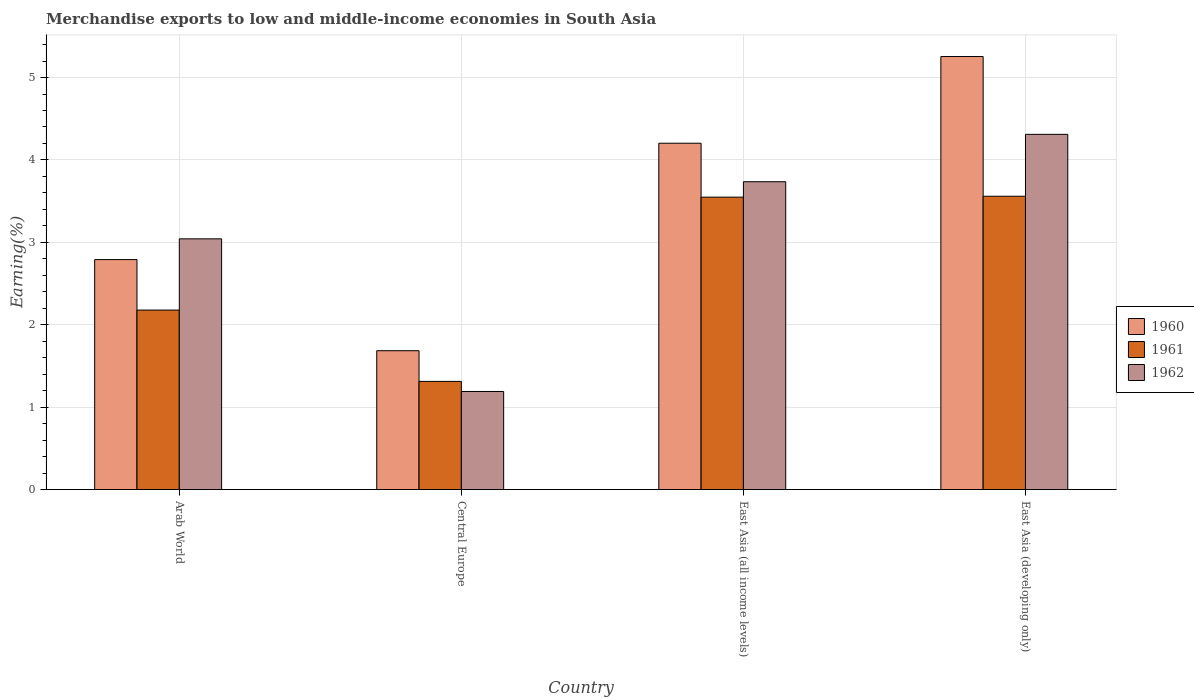How many different coloured bars are there?
Your answer should be compact. 3. How many groups of bars are there?
Offer a terse response. 4. Are the number of bars on each tick of the X-axis equal?
Your response must be concise. Yes. How many bars are there on the 1st tick from the left?
Offer a very short reply. 3. How many bars are there on the 3rd tick from the right?
Offer a terse response. 3. What is the label of the 2nd group of bars from the left?
Make the answer very short. Central Europe. What is the percentage of amount earned from merchandise exports in 1961 in East Asia (all income levels)?
Offer a terse response. 3.55. Across all countries, what is the maximum percentage of amount earned from merchandise exports in 1960?
Your answer should be compact. 5.26. Across all countries, what is the minimum percentage of amount earned from merchandise exports in 1962?
Provide a succinct answer. 1.19. In which country was the percentage of amount earned from merchandise exports in 1962 maximum?
Ensure brevity in your answer.  East Asia (developing only). In which country was the percentage of amount earned from merchandise exports in 1962 minimum?
Ensure brevity in your answer.  Central Europe. What is the total percentage of amount earned from merchandise exports in 1960 in the graph?
Give a very brief answer. 13.93. What is the difference between the percentage of amount earned from merchandise exports in 1961 in Arab World and that in East Asia (all income levels)?
Your response must be concise. -1.37. What is the difference between the percentage of amount earned from merchandise exports in 1962 in East Asia (all income levels) and the percentage of amount earned from merchandise exports in 1960 in Arab World?
Keep it short and to the point. 0.94. What is the average percentage of amount earned from merchandise exports in 1962 per country?
Your answer should be very brief. 3.07. What is the difference between the percentage of amount earned from merchandise exports of/in 1961 and percentage of amount earned from merchandise exports of/in 1960 in Arab World?
Offer a very short reply. -0.61. What is the ratio of the percentage of amount earned from merchandise exports in 1962 in Central Europe to that in East Asia (all income levels)?
Your response must be concise. 0.32. Is the percentage of amount earned from merchandise exports in 1961 in Arab World less than that in East Asia (all income levels)?
Keep it short and to the point. Yes. What is the difference between the highest and the second highest percentage of amount earned from merchandise exports in 1960?
Make the answer very short. -1.41. What is the difference between the highest and the lowest percentage of amount earned from merchandise exports in 1961?
Offer a very short reply. 2.25. What does the 3rd bar from the left in Arab World represents?
Offer a very short reply. 1962. Is it the case that in every country, the sum of the percentage of amount earned from merchandise exports in 1962 and percentage of amount earned from merchandise exports in 1961 is greater than the percentage of amount earned from merchandise exports in 1960?
Your answer should be compact. Yes. How many bars are there?
Offer a terse response. 12. Are all the bars in the graph horizontal?
Give a very brief answer. No. How many countries are there in the graph?
Your response must be concise. 4. Are the values on the major ticks of Y-axis written in scientific E-notation?
Keep it short and to the point. No. Does the graph contain grids?
Your answer should be very brief. Yes. Where does the legend appear in the graph?
Give a very brief answer. Center right. How are the legend labels stacked?
Make the answer very short. Vertical. What is the title of the graph?
Provide a succinct answer. Merchandise exports to low and middle-income economies in South Asia. Does "1976" appear as one of the legend labels in the graph?
Your response must be concise. No. What is the label or title of the X-axis?
Your response must be concise. Country. What is the label or title of the Y-axis?
Make the answer very short. Earning(%). What is the Earning(%) of 1960 in Arab World?
Provide a succinct answer. 2.79. What is the Earning(%) of 1961 in Arab World?
Provide a succinct answer. 2.18. What is the Earning(%) of 1962 in Arab World?
Your answer should be very brief. 3.04. What is the Earning(%) of 1960 in Central Europe?
Provide a succinct answer. 1.68. What is the Earning(%) of 1961 in Central Europe?
Your answer should be compact. 1.31. What is the Earning(%) of 1962 in Central Europe?
Offer a terse response. 1.19. What is the Earning(%) in 1960 in East Asia (all income levels)?
Your answer should be very brief. 4.2. What is the Earning(%) of 1961 in East Asia (all income levels)?
Keep it short and to the point. 3.55. What is the Earning(%) in 1962 in East Asia (all income levels)?
Provide a succinct answer. 3.74. What is the Earning(%) in 1960 in East Asia (developing only)?
Make the answer very short. 5.26. What is the Earning(%) of 1961 in East Asia (developing only)?
Provide a short and direct response. 3.56. What is the Earning(%) in 1962 in East Asia (developing only)?
Provide a short and direct response. 4.31. Across all countries, what is the maximum Earning(%) of 1960?
Your answer should be very brief. 5.26. Across all countries, what is the maximum Earning(%) of 1961?
Give a very brief answer. 3.56. Across all countries, what is the maximum Earning(%) of 1962?
Make the answer very short. 4.31. Across all countries, what is the minimum Earning(%) of 1960?
Your answer should be very brief. 1.68. Across all countries, what is the minimum Earning(%) in 1961?
Ensure brevity in your answer.  1.31. Across all countries, what is the minimum Earning(%) of 1962?
Ensure brevity in your answer.  1.19. What is the total Earning(%) of 1960 in the graph?
Your answer should be compact. 13.93. What is the total Earning(%) of 1961 in the graph?
Keep it short and to the point. 10.6. What is the total Earning(%) of 1962 in the graph?
Give a very brief answer. 12.28. What is the difference between the Earning(%) of 1960 in Arab World and that in Central Europe?
Provide a short and direct response. 1.11. What is the difference between the Earning(%) of 1961 in Arab World and that in Central Europe?
Offer a terse response. 0.87. What is the difference between the Earning(%) in 1962 in Arab World and that in Central Europe?
Ensure brevity in your answer.  1.85. What is the difference between the Earning(%) of 1960 in Arab World and that in East Asia (all income levels)?
Your answer should be very brief. -1.41. What is the difference between the Earning(%) of 1961 in Arab World and that in East Asia (all income levels)?
Offer a terse response. -1.37. What is the difference between the Earning(%) in 1962 in Arab World and that in East Asia (all income levels)?
Ensure brevity in your answer.  -0.69. What is the difference between the Earning(%) of 1960 in Arab World and that in East Asia (developing only)?
Your answer should be very brief. -2.46. What is the difference between the Earning(%) in 1961 in Arab World and that in East Asia (developing only)?
Ensure brevity in your answer.  -1.38. What is the difference between the Earning(%) in 1962 in Arab World and that in East Asia (developing only)?
Provide a succinct answer. -1.27. What is the difference between the Earning(%) in 1960 in Central Europe and that in East Asia (all income levels)?
Your response must be concise. -2.52. What is the difference between the Earning(%) of 1961 in Central Europe and that in East Asia (all income levels)?
Offer a terse response. -2.24. What is the difference between the Earning(%) in 1962 in Central Europe and that in East Asia (all income levels)?
Provide a short and direct response. -2.55. What is the difference between the Earning(%) of 1960 in Central Europe and that in East Asia (developing only)?
Your response must be concise. -3.57. What is the difference between the Earning(%) of 1961 in Central Europe and that in East Asia (developing only)?
Your answer should be compact. -2.25. What is the difference between the Earning(%) in 1962 in Central Europe and that in East Asia (developing only)?
Provide a succinct answer. -3.12. What is the difference between the Earning(%) in 1960 in East Asia (all income levels) and that in East Asia (developing only)?
Offer a terse response. -1.05. What is the difference between the Earning(%) in 1961 in East Asia (all income levels) and that in East Asia (developing only)?
Give a very brief answer. -0.01. What is the difference between the Earning(%) in 1962 in East Asia (all income levels) and that in East Asia (developing only)?
Provide a succinct answer. -0.57. What is the difference between the Earning(%) in 1960 in Arab World and the Earning(%) in 1961 in Central Europe?
Your answer should be very brief. 1.48. What is the difference between the Earning(%) in 1960 in Arab World and the Earning(%) in 1962 in Central Europe?
Your response must be concise. 1.6. What is the difference between the Earning(%) of 1960 in Arab World and the Earning(%) of 1961 in East Asia (all income levels)?
Keep it short and to the point. -0.76. What is the difference between the Earning(%) in 1960 in Arab World and the Earning(%) in 1962 in East Asia (all income levels)?
Give a very brief answer. -0.94. What is the difference between the Earning(%) in 1961 in Arab World and the Earning(%) in 1962 in East Asia (all income levels)?
Offer a terse response. -1.56. What is the difference between the Earning(%) of 1960 in Arab World and the Earning(%) of 1961 in East Asia (developing only)?
Keep it short and to the point. -0.77. What is the difference between the Earning(%) of 1960 in Arab World and the Earning(%) of 1962 in East Asia (developing only)?
Ensure brevity in your answer.  -1.52. What is the difference between the Earning(%) in 1961 in Arab World and the Earning(%) in 1962 in East Asia (developing only)?
Offer a very short reply. -2.13. What is the difference between the Earning(%) of 1960 in Central Europe and the Earning(%) of 1961 in East Asia (all income levels)?
Ensure brevity in your answer.  -1.86. What is the difference between the Earning(%) of 1960 in Central Europe and the Earning(%) of 1962 in East Asia (all income levels)?
Provide a succinct answer. -2.05. What is the difference between the Earning(%) in 1961 in Central Europe and the Earning(%) in 1962 in East Asia (all income levels)?
Provide a short and direct response. -2.42. What is the difference between the Earning(%) in 1960 in Central Europe and the Earning(%) in 1961 in East Asia (developing only)?
Your response must be concise. -1.87. What is the difference between the Earning(%) in 1960 in Central Europe and the Earning(%) in 1962 in East Asia (developing only)?
Your response must be concise. -2.63. What is the difference between the Earning(%) in 1961 in Central Europe and the Earning(%) in 1962 in East Asia (developing only)?
Offer a very short reply. -3. What is the difference between the Earning(%) of 1960 in East Asia (all income levels) and the Earning(%) of 1961 in East Asia (developing only)?
Your answer should be compact. 0.64. What is the difference between the Earning(%) in 1960 in East Asia (all income levels) and the Earning(%) in 1962 in East Asia (developing only)?
Offer a terse response. -0.11. What is the difference between the Earning(%) in 1961 in East Asia (all income levels) and the Earning(%) in 1962 in East Asia (developing only)?
Keep it short and to the point. -0.76. What is the average Earning(%) of 1960 per country?
Ensure brevity in your answer.  3.48. What is the average Earning(%) in 1961 per country?
Your answer should be compact. 2.65. What is the average Earning(%) in 1962 per country?
Make the answer very short. 3.07. What is the difference between the Earning(%) of 1960 and Earning(%) of 1961 in Arab World?
Offer a terse response. 0.61. What is the difference between the Earning(%) in 1960 and Earning(%) in 1962 in Arab World?
Your answer should be compact. -0.25. What is the difference between the Earning(%) in 1961 and Earning(%) in 1962 in Arab World?
Provide a succinct answer. -0.86. What is the difference between the Earning(%) in 1960 and Earning(%) in 1961 in Central Europe?
Your response must be concise. 0.37. What is the difference between the Earning(%) of 1960 and Earning(%) of 1962 in Central Europe?
Ensure brevity in your answer.  0.49. What is the difference between the Earning(%) of 1961 and Earning(%) of 1962 in Central Europe?
Provide a succinct answer. 0.12. What is the difference between the Earning(%) in 1960 and Earning(%) in 1961 in East Asia (all income levels)?
Offer a terse response. 0.65. What is the difference between the Earning(%) of 1960 and Earning(%) of 1962 in East Asia (all income levels)?
Provide a succinct answer. 0.47. What is the difference between the Earning(%) in 1961 and Earning(%) in 1962 in East Asia (all income levels)?
Your answer should be compact. -0.19. What is the difference between the Earning(%) of 1960 and Earning(%) of 1961 in East Asia (developing only)?
Your answer should be very brief. 1.7. What is the difference between the Earning(%) of 1960 and Earning(%) of 1962 in East Asia (developing only)?
Your answer should be compact. 0.94. What is the difference between the Earning(%) of 1961 and Earning(%) of 1962 in East Asia (developing only)?
Offer a very short reply. -0.75. What is the ratio of the Earning(%) of 1960 in Arab World to that in Central Europe?
Ensure brevity in your answer.  1.66. What is the ratio of the Earning(%) of 1961 in Arab World to that in Central Europe?
Your answer should be compact. 1.66. What is the ratio of the Earning(%) in 1962 in Arab World to that in Central Europe?
Your response must be concise. 2.56. What is the ratio of the Earning(%) in 1960 in Arab World to that in East Asia (all income levels)?
Your answer should be compact. 0.66. What is the ratio of the Earning(%) of 1961 in Arab World to that in East Asia (all income levels)?
Provide a succinct answer. 0.61. What is the ratio of the Earning(%) of 1962 in Arab World to that in East Asia (all income levels)?
Your answer should be compact. 0.81. What is the ratio of the Earning(%) in 1960 in Arab World to that in East Asia (developing only)?
Keep it short and to the point. 0.53. What is the ratio of the Earning(%) of 1961 in Arab World to that in East Asia (developing only)?
Make the answer very short. 0.61. What is the ratio of the Earning(%) in 1962 in Arab World to that in East Asia (developing only)?
Provide a succinct answer. 0.71. What is the ratio of the Earning(%) of 1960 in Central Europe to that in East Asia (all income levels)?
Your answer should be very brief. 0.4. What is the ratio of the Earning(%) of 1961 in Central Europe to that in East Asia (all income levels)?
Give a very brief answer. 0.37. What is the ratio of the Earning(%) of 1962 in Central Europe to that in East Asia (all income levels)?
Offer a very short reply. 0.32. What is the ratio of the Earning(%) in 1960 in Central Europe to that in East Asia (developing only)?
Provide a succinct answer. 0.32. What is the ratio of the Earning(%) in 1961 in Central Europe to that in East Asia (developing only)?
Provide a short and direct response. 0.37. What is the ratio of the Earning(%) of 1962 in Central Europe to that in East Asia (developing only)?
Your answer should be very brief. 0.28. What is the ratio of the Earning(%) in 1960 in East Asia (all income levels) to that in East Asia (developing only)?
Provide a short and direct response. 0.8. What is the ratio of the Earning(%) of 1961 in East Asia (all income levels) to that in East Asia (developing only)?
Keep it short and to the point. 1. What is the ratio of the Earning(%) in 1962 in East Asia (all income levels) to that in East Asia (developing only)?
Give a very brief answer. 0.87. What is the difference between the highest and the second highest Earning(%) of 1960?
Offer a very short reply. 1.05. What is the difference between the highest and the second highest Earning(%) of 1961?
Make the answer very short. 0.01. What is the difference between the highest and the second highest Earning(%) of 1962?
Your response must be concise. 0.57. What is the difference between the highest and the lowest Earning(%) of 1960?
Your answer should be very brief. 3.57. What is the difference between the highest and the lowest Earning(%) of 1961?
Make the answer very short. 2.25. What is the difference between the highest and the lowest Earning(%) in 1962?
Your answer should be very brief. 3.12. 